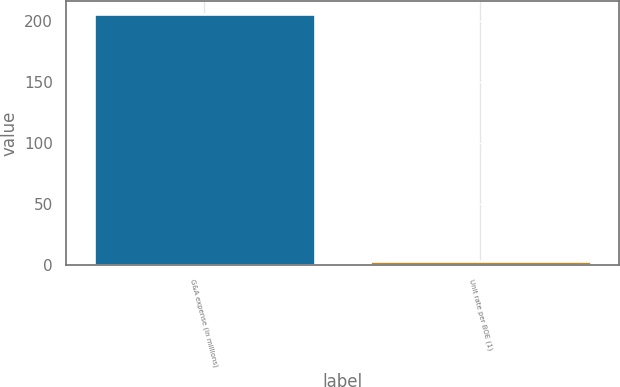Convert chart. <chart><loc_0><loc_0><loc_500><loc_500><bar_chart><fcel>G&A expense (in millions)<fcel>Unit rate per BOE (1)<nl><fcel>206<fcel>2.96<nl></chart> 